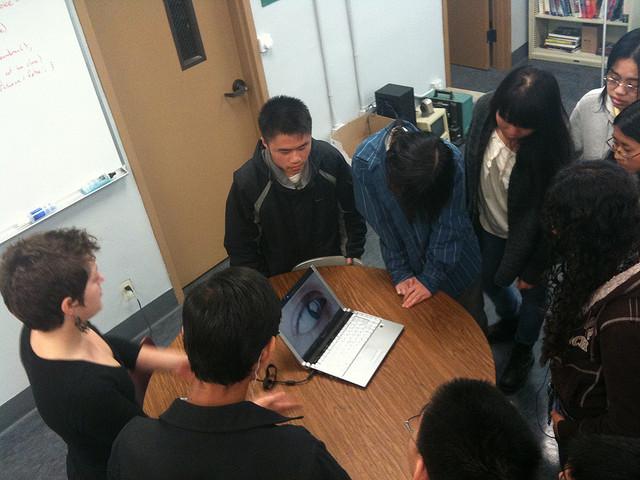Is this a classroom?
Give a very brief answer. Yes. What is on the table?
Be succinct. Laptop. What are the people looking at?
Be succinct. Laptop. 